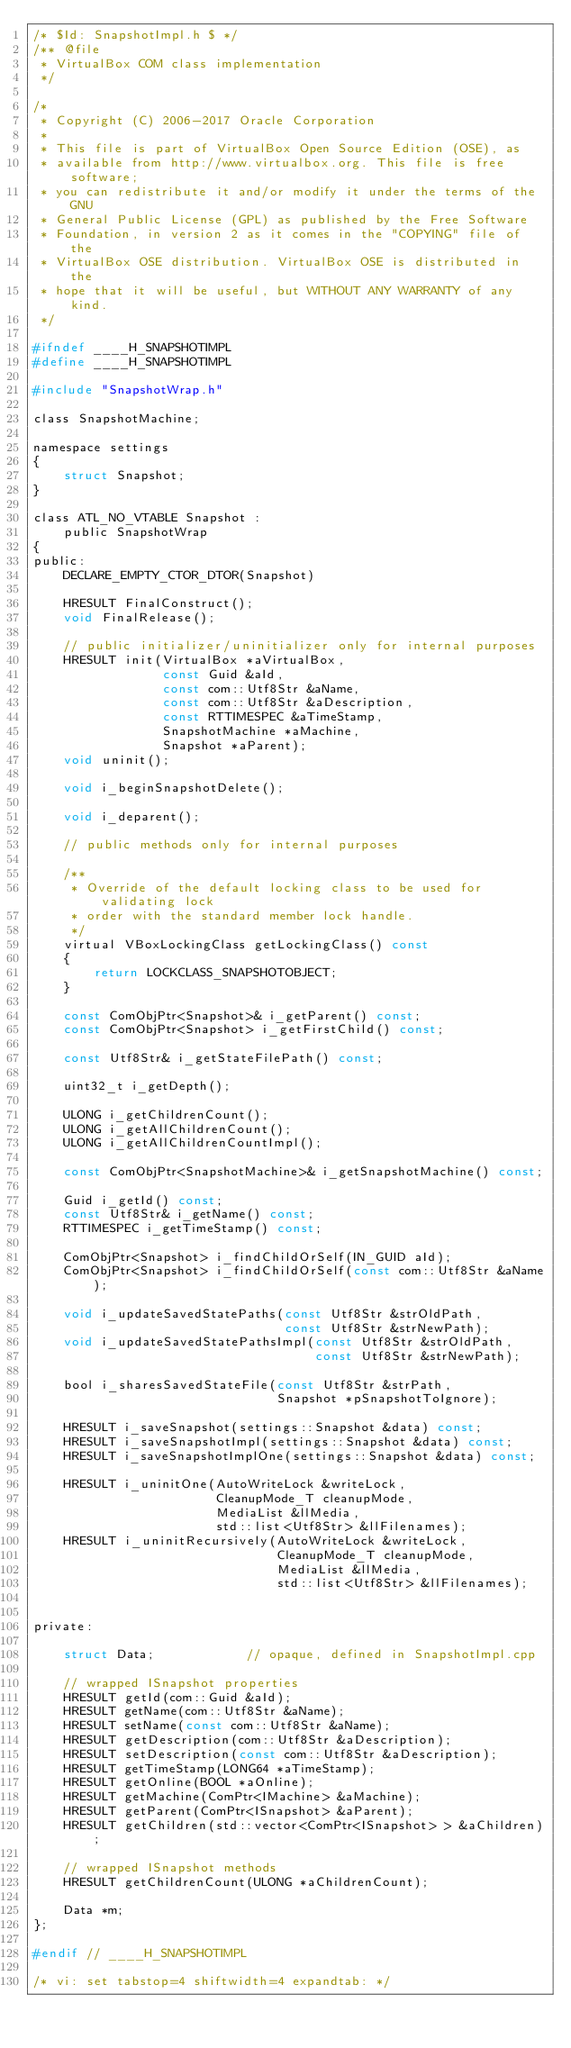Convert code to text. <code><loc_0><loc_0><loc_500><loc_500><_C_>/* $Id: SnapshotImpl.h $ */
/** @file
 * VirtualBox COM class implementation
 */

/*
 * Copyright (C) 2006-2017 Oracle Corporation
 *
 * This file is part of VirtualBox Open Source Edition (OSE), as
 * available from http://www.virtualbox.org. This file is free software;
 * you can redistribute it and/or modify it under the terms of the GNU
 * General Public License (GPL) as published by the Free Software
 * Foundation, in version 2 as it comes in the "COPYING" file of the
 * VirtualBox OSE distribution. VirtualBox OSE is distributed in the
 * hope that it will be useful, but WITHOUT ANY WARRANTY of any kind.
 */

#ifndef ____H_SNAPSHOTIMPL
#define ____H_SNAPSHOTIMPL

#include "SnapshotWrap.h"

class SnapshotMachine;

namespace settings
{
    struct Snapshot;
}

class ATL_NO_VTABLE Snapshot :
    public SnapshotWrap
{
public:
    DECLARE_EMPTY_CTOR_DTOR(Snapshot)

    HRESULT FinalConstruct();
    void FinalRelease();

    // public initializer/uninitializer only for internal purposes
    HRESULT init(VirtualBox *aVirtualBox,
                 const Guid &aId,
                 const com::Utf8Str &aName,
                 const com::Utf8Str &aDescription,
                 const RTTIMESPEC &aTimeStamp,
                 SnapshotMachine *aMachine,
                 Snapshot *aParent);
    void uninit();

    void i_beginSnapshotDelete();

    void i_deparent();

    // public methods only for internal purposes

    /**
     * Override of the default locking class to be used for validating lock
     * order with the standard member lock handle.
     */
    virtual VBoxLockingClass getLockingClass() const
    {
        return LOCKCLASS_SNAPSHOTOBJECT;
    }

    const ComObjPtr<Snapshot>& i_getParent() const;
    const ComObjPtr<Snapshot> i_getFirstChild() const;

    const Utf8Str& i_getStateFilePath() const;

    uint32_t i_getDepth();

    ULONG i_getChildrenCount();
    ULONG i_getAllChildrenCount();
    ULONG i_getAllChildrenCountImpl();

    const ComObjPtr<SnapshotMachine>& i_getSnapshotMachine() const;

    Guid i_getId() const;
    const Utf8Str& i_getName() const;
    RTTIMESPEC i_getTimeStamp() const;

    ComObjPtr<Snapshot> i_findChildOrSelf(IN_GUID aId);
    ComObjPtr<Snapshot> i_findChildOrSelf(const com::Utf8Str &aName);

    void i_updateSavedStatePaths(const Utf8Str &strOldPath,
                                 const Utf8Str &strNewPath);
    void i_updateSavedStatePathsImpl(const Utf8Str &strOldPath,
                                     const Utf8Str &strNewPath);

    bool i_sharesSavedStateFile(const Utf8Str &strPath,
                                Snapshot *pSnapshotToIgnore);

    HRESULT i_saveSnapshot(settings::Snapshot &data) const;
    HRESULT i_saveSnapshotImpl(settings::Snapshot &data) const;
    HRESULT i_saveSnapshotImplOne(settings::Snapshot &data) const;

    HRESULT i_uninitOne(AutoWriteLock &writeLock,
                        CleanupMode_T cleanupMode,
                        MediaList &llMedia,
                        std::list<Utf8Str> &llFilenames);
    HRESULT i_uninitRecursively(AutoWriteLock &writeLock,
                                CleanupMode_T cleanupMode,
                                MediaList &llMedia,
                                std::list<Utf8Str> &llFilenames);


private:

    struct Data;            // opaque, defined in SnapshotImpl.cpp

    // wrapped ISnapshot properties
    HRESULT getId(com::Guid &aId);
    HRESULT getName(com::Utf8Str &aName);
    HRESULT setName(const com::Utf8Str &aName);
    HRESULT getDescription(com::Utf8Str &aDescription);
    HRESULT setDescription(const com::Utf8Str &aDescription);
    HRESULT getTimeStamp(LONG64 *aTimeStamp);
    HRESULT getOnline(BOOL *aOnline);
    HRESULT getMachine(ComPtr<IMachine> &aMachine);
    HRESULT getParent(ComPtr<ISnapshot> &aParent);
    HRESULT getChildren(std::vector<ComPtr<ISnapshot> > &aChildren);

    // wrapped ISnapshot methods
    HRESULT getChildrenCount(ULONG *aChildrenCount);

    Data *m;
};

#endif // ____H_SNAPSHOTIMPL

/* vi: set tabstop=4 shiftwidth=4 expandtab: */
</code> 